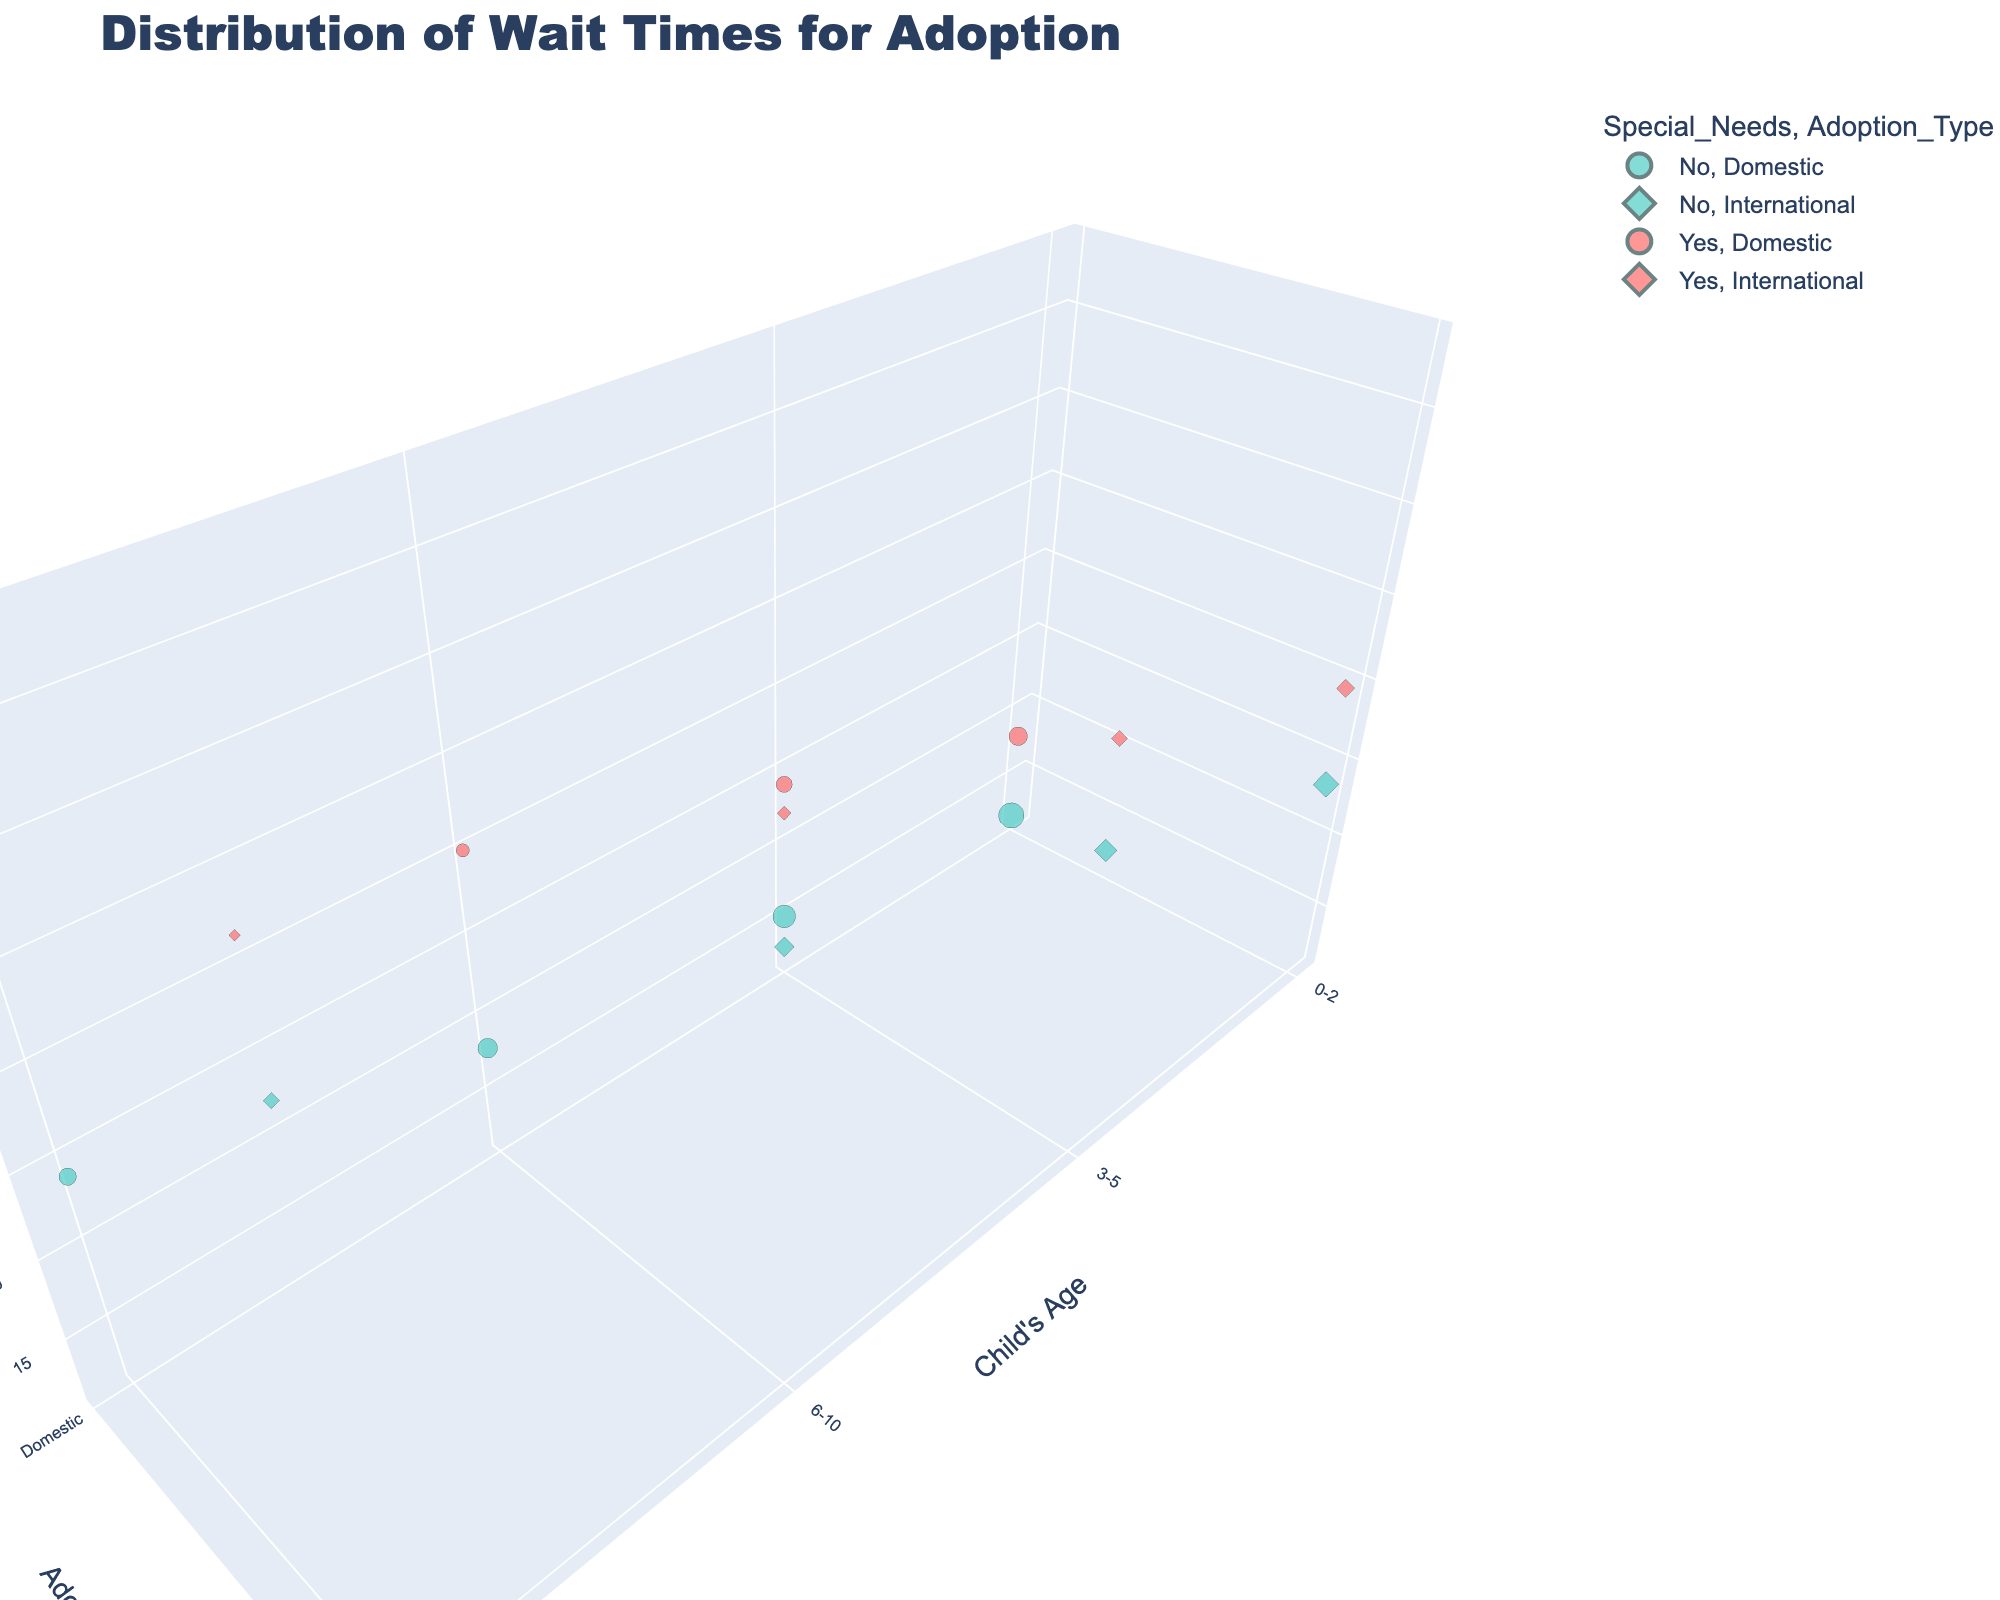What is the title of the figure? The title is usually displayed at the top of the figure. In this case, the given code specifies the title as 'Distribution of Wait Times for Adoption'.
Answer: Distribution of Wait Times for Adoption What are the axes labels in the chart? The code defines labels for three axes. The x-axis is labeled 'Child's Age', the y-axis is labeled 'Adoption Type', and the z-axis is labeled 'Wait Time (Months)'.
Answer: Child's Age, Adoption Type, Wait Time (Months) Which adoption type between 'Domestic' and 'International' generally has longer wait times for children without special needs? By comparing the z-axis values (Wait Time) for 'Domestic' and 'International' adoption types for children without special needs across all age groups, we can observe that 'International' wait times are consistently higher.
Answer: International How does the number of children adopted domestically without special needs compare between ages 0-2 and 6-10? Look at the bubble sizes for 'Domestic', 'No' special needs, and compare '0-2' and '6-10' age categories. The bubble for age '0-2' is larger (150) compared to the bubble for age '6-10' (90).
Answer: 0-2 has a larger number of children Which age category has the longest wait time for international adoptions with special needs? Check the z-axis value for international adoptions with special needs across age categories. Age '11-17' has the longest wait time at 48 months.
Answer: 11-17 Is there a significant difference in wait times for domestic adoptions with special needs between ages 3-5 and 11-17? Compare the z-axis values for 'Domestic' adoptions with special needs for ages 3-5 (24 months) and 11-17 (36 months). There is a difference of 12 months.
Answer: Yes, 12 months How does the wait time for domestic adoptions with no special needs change as the age of the child increases? Observing the z-axis values for 'Domestic' adoptions with no special needs: 
Ages 0-2 (12 months), 3-5 (15 months), 6-10 (18 months), and 11-17 (24 months), the wait time increases with age.
Answer: The wait time increases For international adoptions with special needs, how much greater is the wait time for children aged 11-17 compared to children aged 0-2? The wait time for 'International' adoptions with special needs for ages 11-17 is 48 months, and for ages 0-2, it is 30 months. The difference is 48 - 30 = 18 months.
Answer: 18 months What is the color representation used for special needs children in the chart? The chart uses different colors for children with and without special needs. Children with special needs are represented by a red-like color.
Answer: Red How many children aged 3-5 with no special needs were adopted domestically? Look at the size of the bubble corresponding to '3-5', 'No', 'Domestic'. The size indicates the number as 120.
Answer: 120 